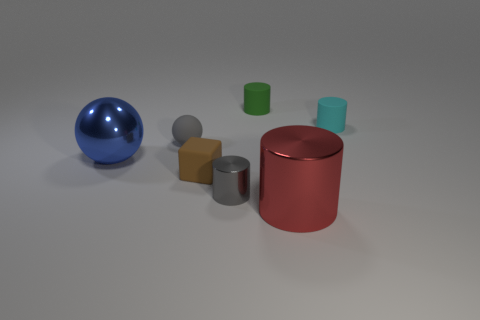There is a gray thing that is the same shape as the cyan thing; what is its material?
Make the answer very short. Metal. There is a tiny object that is right of the brown object and in front of the large blue metal object; what material is it made of?
Offer a terse response. Metal. Are there fewer tiny cylinders that are in front of the red metal thing than rubber cylinders left of the cyan cylinder?
Offer a very short reply. Yes. What number of other objects are there of the same size as the metal ball?
Offer a very short reply. 1. There is a large object that is to the left of the small gray thing that is behind the big thing that is on the left side of the green matte thing; what is its shape?
Ensure brevity in your answer.  Sphere. How many blue things are cubes or spheres?
Ensure brevity in your answer.  1. There is a small gray object in front of the big sphere; how many red metallic things are behind it?
Offer a very short reply. 0. Are there any other things of the same color as the big ball?
Offer a very short reply. No. There is a brown thing that is made of the same material as the tiny sphere; what shape is it?
Give a very brief answer. Cube. Is the rubber sphere the same color as the rubber block?
Keep it short and to the point. No. 